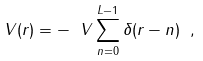<formula> <loc_0><loc_0><loc_500><loc_500>V ( r ) = - \ V \sum _ { n = 0 } ^ { L - 1 } \delta ( r - n ) \ ,</formula> 